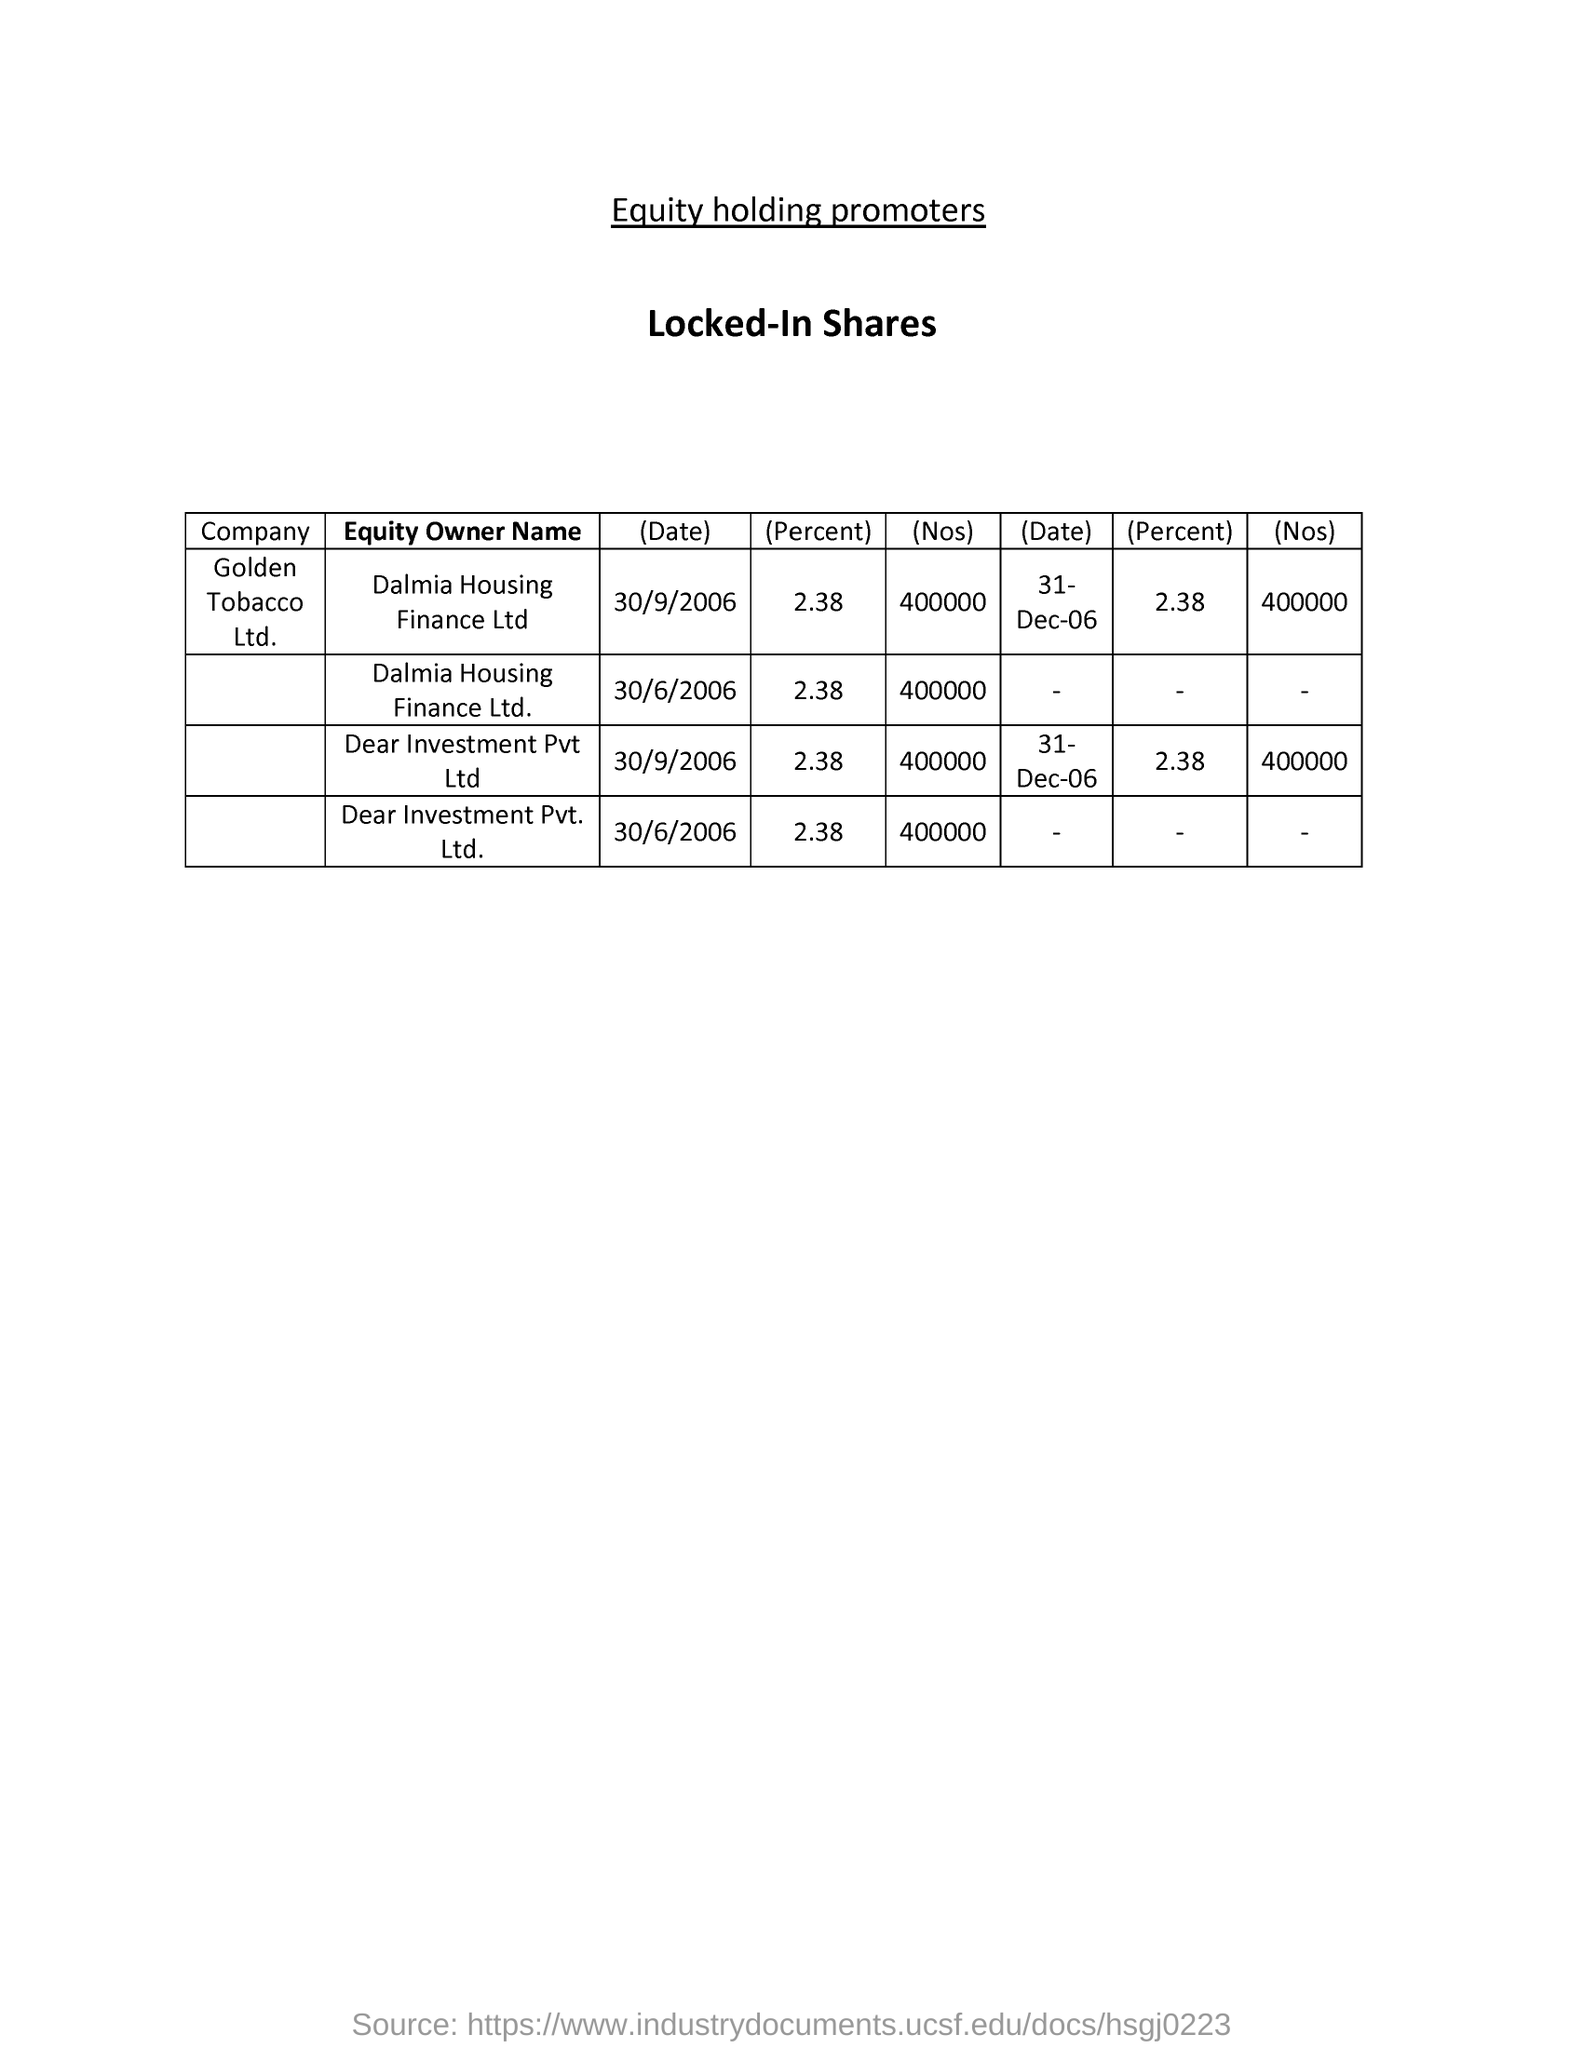Outline some significant characteristics in this image. It is being stated that the mentioned shares are "locked-in shares. 